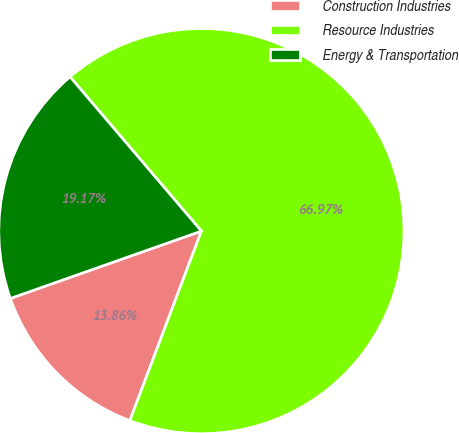Convert chart to OTSL. <chart><loc_0><loc_0><loc_500><loc_500><pie_chart><fcel>Construction Industries<fcel>Resource Industries<fcel>Energy & Transportation<nl><fcel>13.86%<fcel>66.97%<fcel>19.17%<nl></chart> 